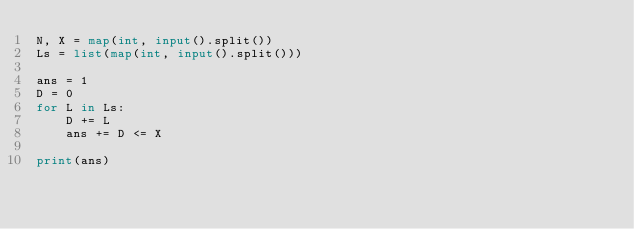<code> <loc_0><loc_0><loc_500><loc_500><_Python_>N, X = map(int, input().split())
Ls = list(map(int, input().split()))

ans = 1
D = 0
for L in Ls:
    D += L
    ans += D <= X

print(ans)
</code> 